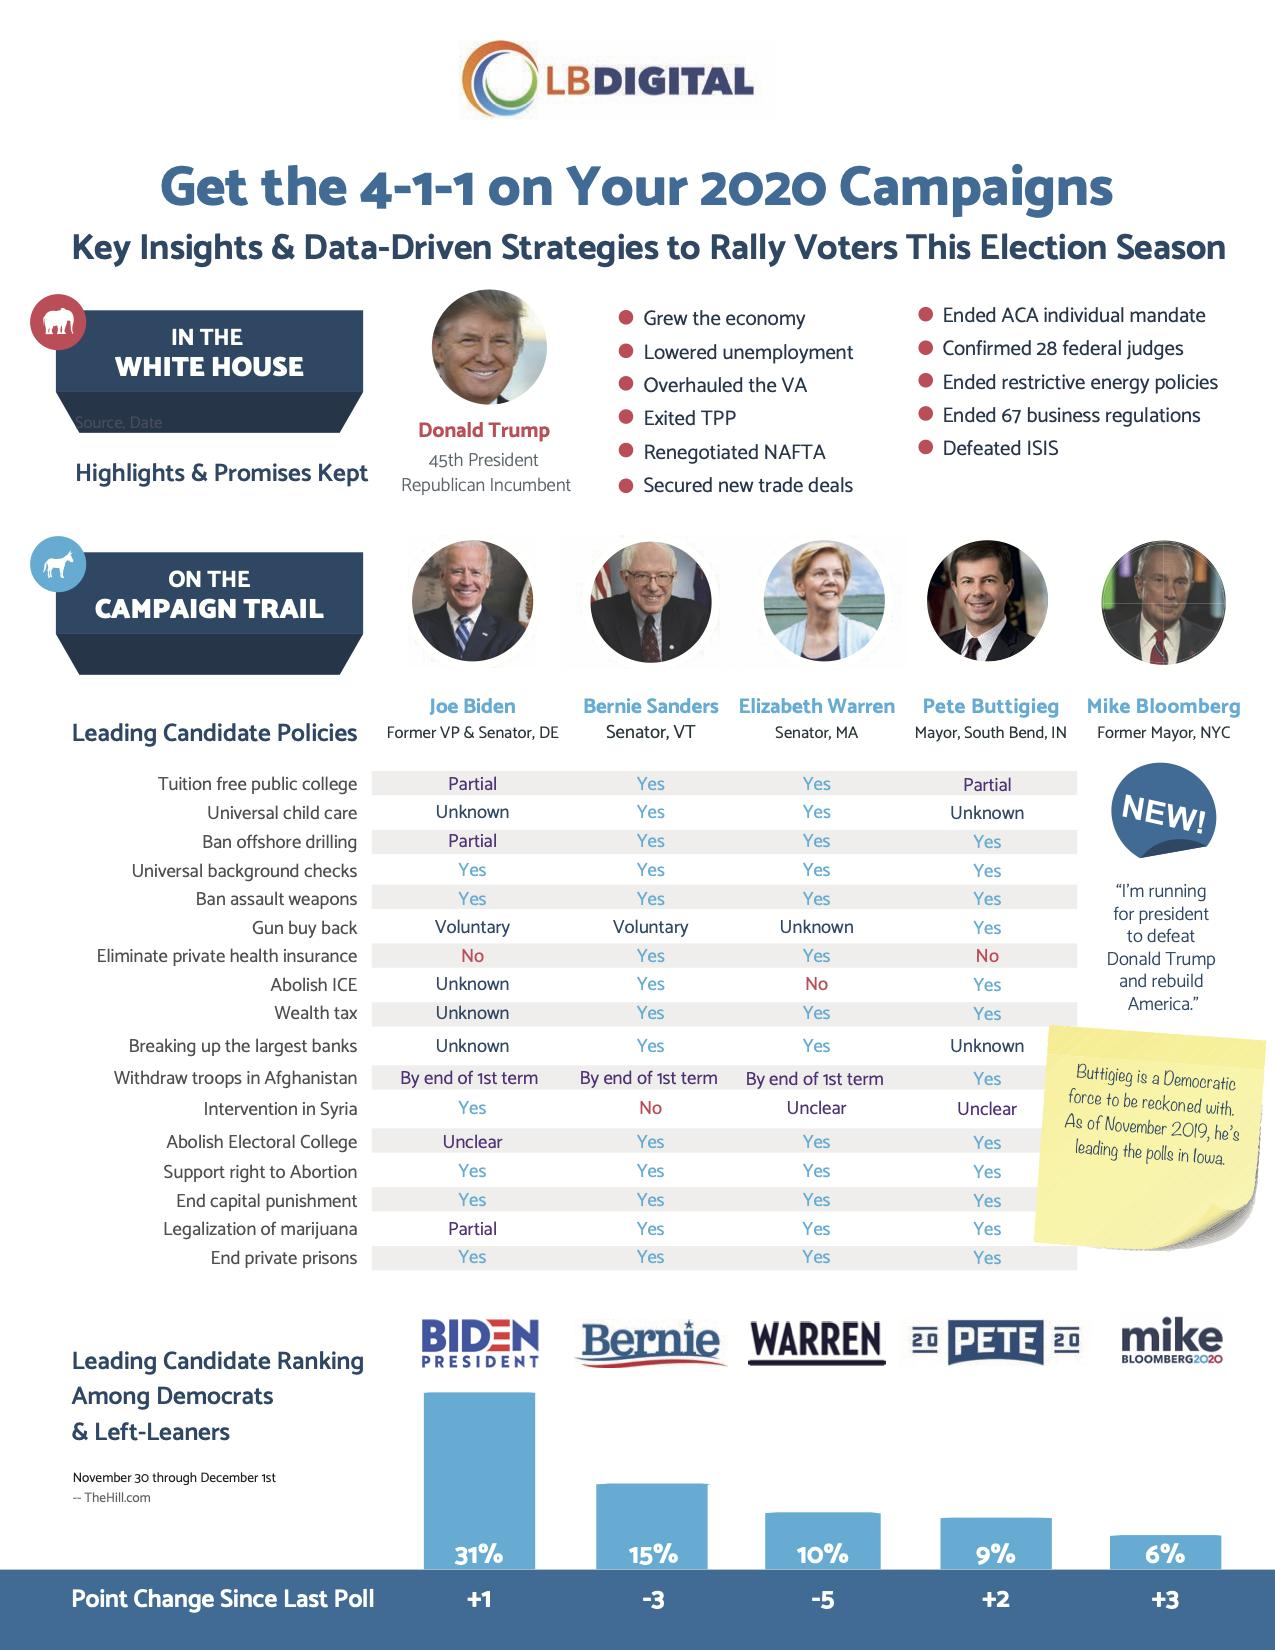Mention a couple of crucial points in this snapshot. Bernie Sanders has the second-highest chance of winning the presidential election. Two candidates rejected the proposal to eliminate private health insurance. Mike Bloomberg, a former mayor of New York City, is a candidate for the Democratic nomination for president in the upcoming election. Joe Biden discourages the policy of eliminating private health insurance. 